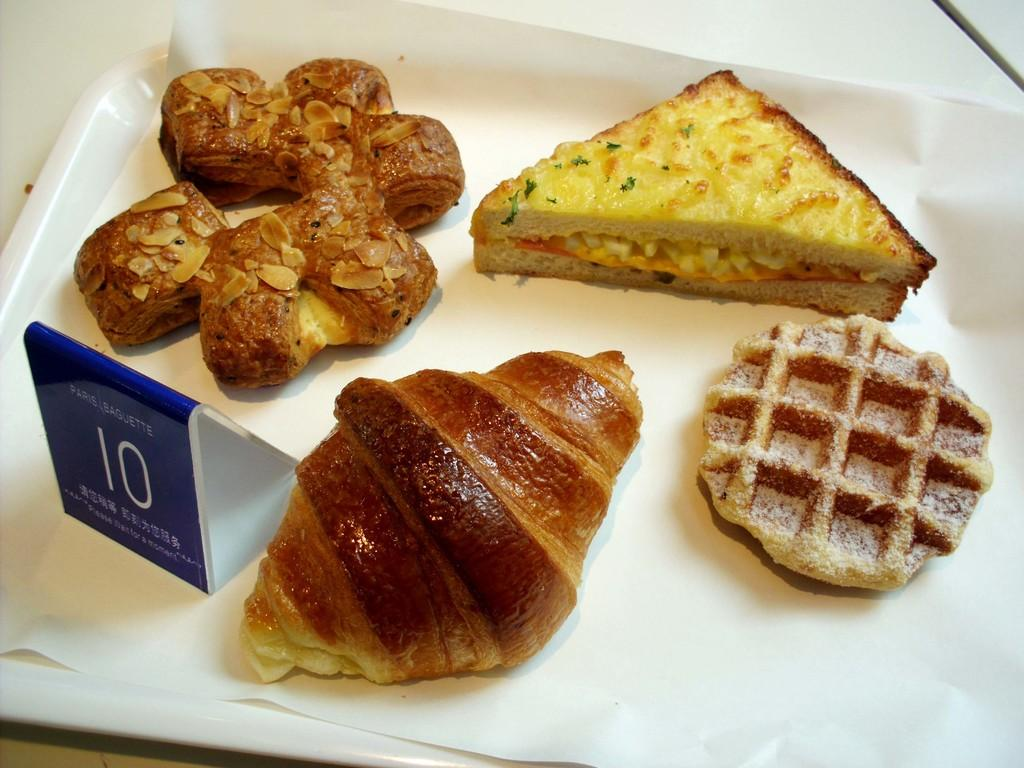What object is present in the image that can hold items? There is a tray in the image that can hold items. What is written on the tray? There is a name board on the tray. What type of items can be seen on the tray? There is food on the tray. Where is the tray located in the image? The tray is placed on a platform. Can you hear a whistle in the image? There is no whistle present in the image. What type of birds can be seen on the tray? There are no birds present in the image. 